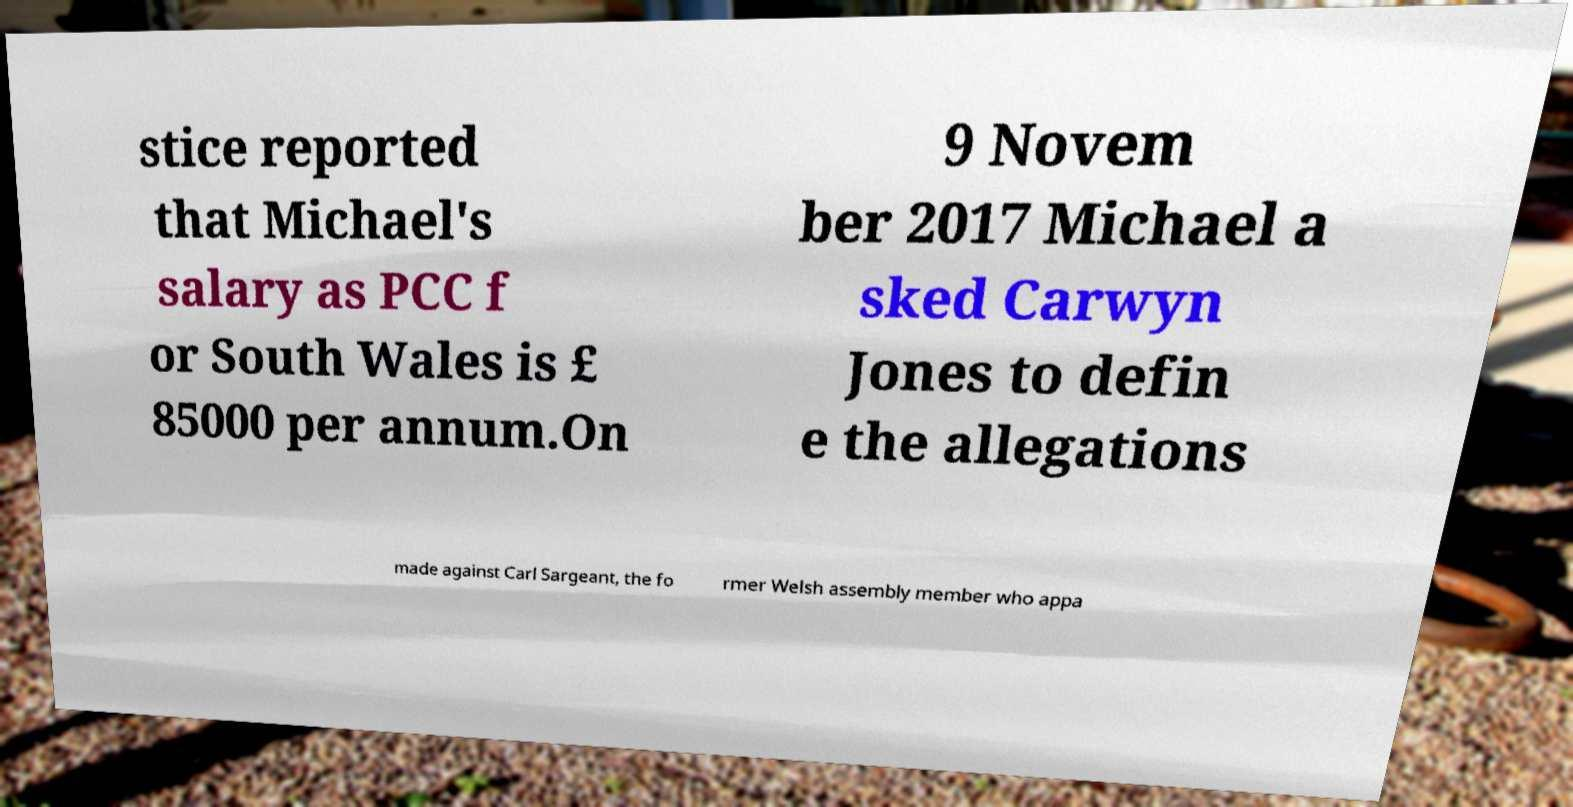Can you read and provide the text displayed in the image?This photo seems to have some interesting text. Can you extract and type it out for me? stice reported that Michael's salary as PCC f or South Wales is £ 85000 per annum.On 9 Novem ber 2017 Michael a sked Carwyn Jones to defin e the allegations made against Carl Sargeant, the fo rmer Welsh assembly member who appa 